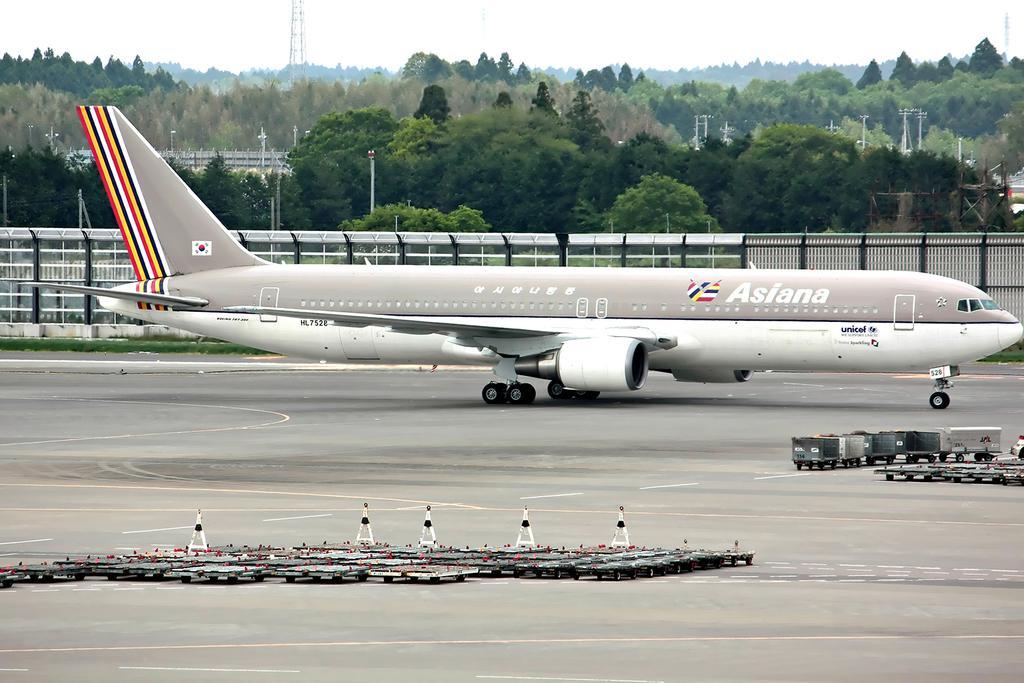Could you give a brief overview of what you see in this image? In this image we can see an airplane, there are some traffic cones, trucks, there are some objects on the runway, there is a fencing, trees, poles, towers, also we can see the sky. 